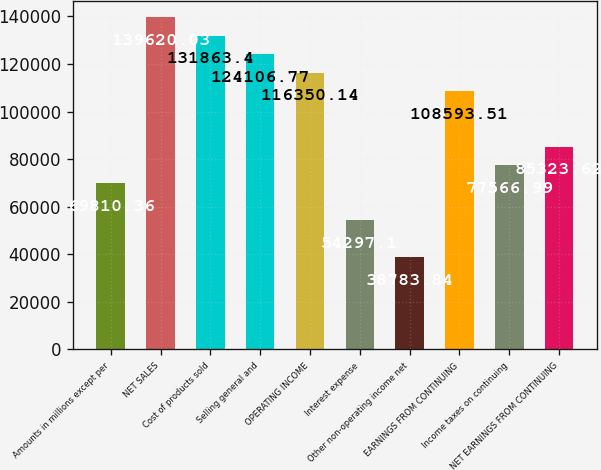Convert chart to OTSL. <chart><loc_0><loc_0><loc_500><loc_500><bar_chart><fcel>Amounts in millions except per<fcel>NET SALES<fcel>Cost of products sold<fcel>Selling general and<fcel>OPERATING INCOME<fcel>Interest expense<fcel>Other non-operating income net<fcel>EARNINGS FROM CONTINUING<fcel>Income taxes on continuing<fcel>NET EARNINGS FROM CONTINUING<nl><fcel>69810.4<fcel>139620<fcel>131863<fcel>124107<fcel>116350<fcel>54297.1<fcel>38783.8<fcel>108594<fcel>77567<fcel>85323.6<nl></chart> 